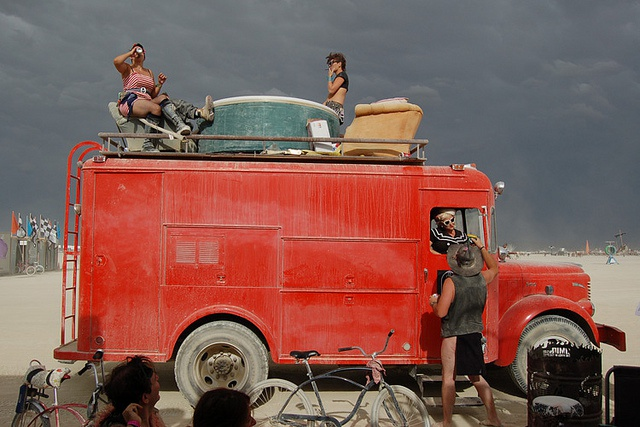Describe the objects in this image and their specific colors. I can see truck in gray, brown, and red tones, bicycle in gray, tan, and black tones, people in gray, black, maroon, and brown tones, bicycle in gray, black, and maroon tones, and people in gray, black, and maroon tones in this image. 